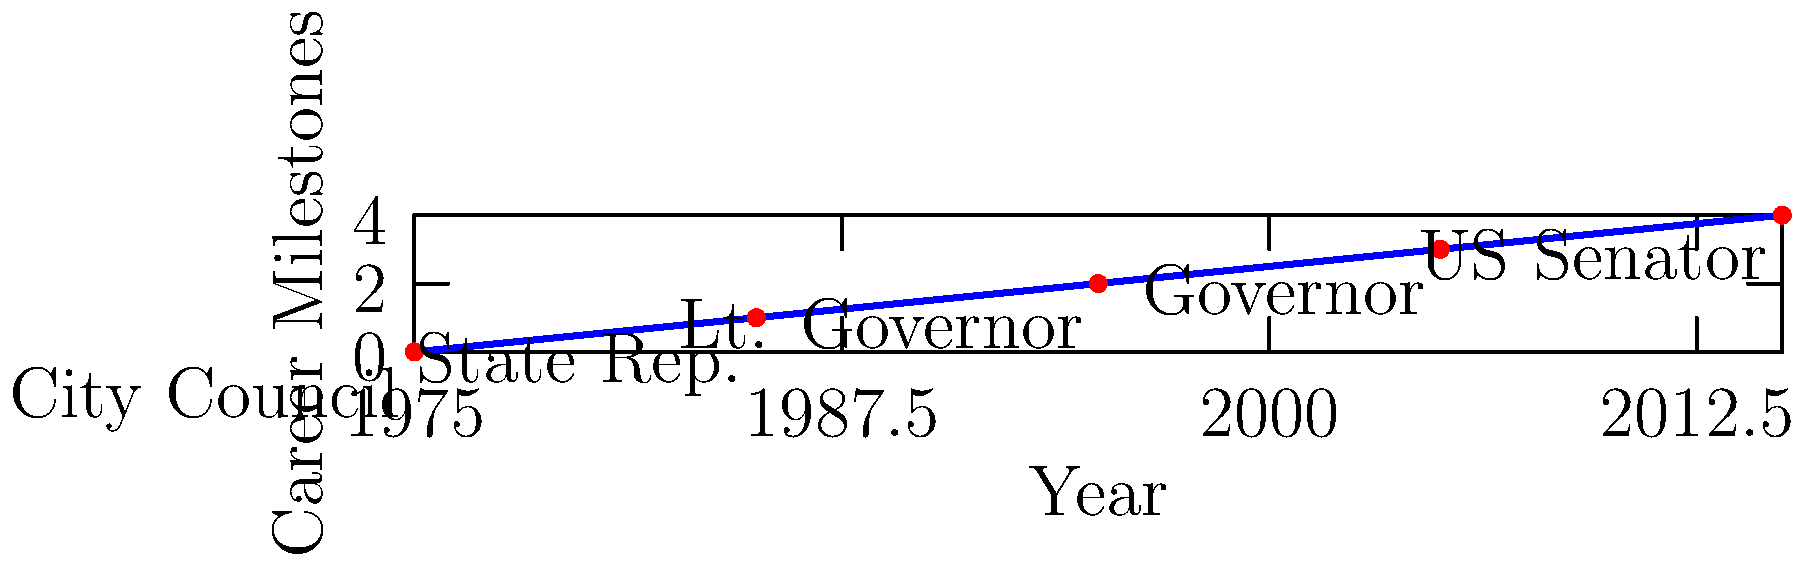The timeline above shows the career progression of Jeanne Shaheen, a lesser-known female politician from New Hampshire. In which year did she become the state's first female governor? To answer this question, we need to analyze the timeline provided:

1. The timeline shows Jeanne Shaheen's career milestones from 1975 to 2015.
2. Each point on the graph represents a significant position she held.
3. The positions are labeled in chronological order:
   - 1975: City Council
   - 1985: State Representative
   - 1995: Lieutenant Governor
   - 2005: Governor
   - 2015: US Senator
4. The question asks specifically about when she became governor.
5. Looking at the timeline, we can see that the "Governor" position corresponds to the year 2005.

Therefore, Jeanne Shaheen became New Hampshire's first female governor in 2005.
Answer: 2005 